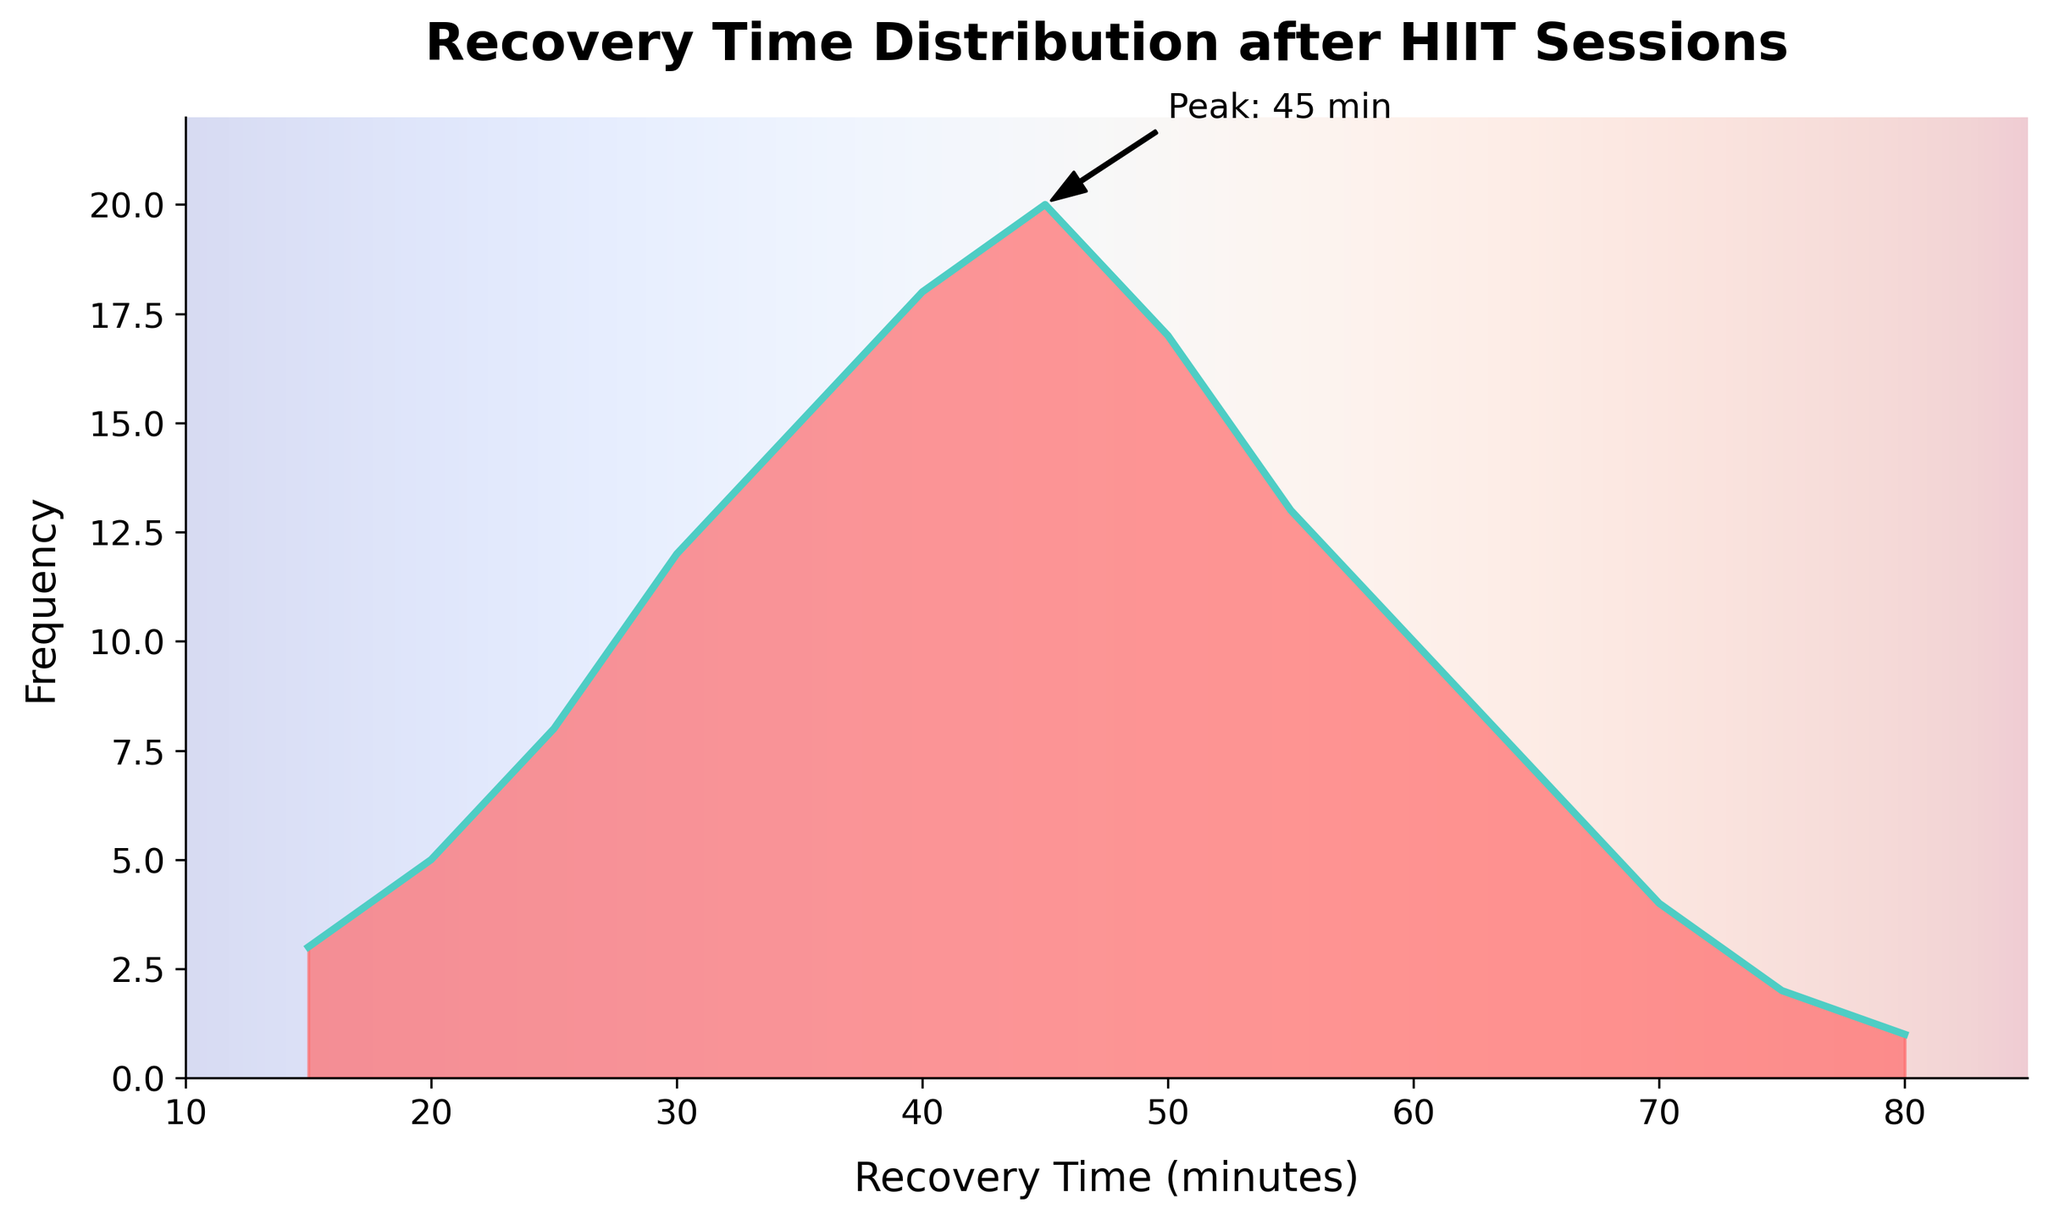What is the title of the figure? The title of the figure is displayed prominently at the top and reads "Recovery Time Distribution after HIIT Sessions."
Answer: Recovery Time Distribution after HIIT Sessions What does the x-axis represent? The x-axis label is written as "Recovery Time (minutes)," indicating it represents recovery time in minutes.
Answer: Recovery Time (minutes) What is the color of the area under the density curve? The area under the curve is shaded in red tones, indicating it uses a color similar to a gradient of red.
Answer: Red tones Which recovery time has the highest frequency? The label and annotation near the peak indicate that the highest frequency occurs at 45 minutes.
Answer: 45 minutes Between which two values are the maximum density portions situated? Observing the density curve, the highest densities are primarily between 30 and 50 minutes.
Answer: 30 to 50 minutes How does the frequency at 30 minutes compare to that at 50 minutes? The frequency at 30 minutes is 12 and at 50 minutes is 17, so 50 minutes has a higher frequency.
Answer: 50 minutes has a higher frequency What is the frequency difference between the recovery times with the highest and lowest frequencies? The highest frequency is 20 (at 45 minutes) and the lowest is 1 (at 80 minutes). So, the difference is 20 - 1 = 19.
Answer: 19 What is the sum of frequencies for recovery times less than or equal to 40 minutes? Recovery times less than or equal to 40 minutes include 15, 20, 25, 30, 35, and 40 minutes. Their frequencies are 3, 5, 8, 12, 15, and 18. Summing these gives 3 + 5 + 8 + 12 + 15 + 18 = 61.
Answer: 61 What range of recovery times has frequencies greater than 15? Checking the frequencies, recovery times 35, 40, 45, and 50 minutes all have frequencies greater than 15.
Answer: 35 to 50 minutes What is the average recovery time weighted by frequency? Calculating the weighted average: (15*3 + 20*5 + 25*8 + 30*12 + 35*15 + 40*18 + 45*20 + 50*17 + 55*13 + 60*10 + 65*7 + 70*4 + 75*2 + 80*1) / (3+5+8+12+15+18+20+17+13+10+7+4+2+1) = 18500 / 135 ≈ 37.41
Answer: ≈ 37.41 minutes 